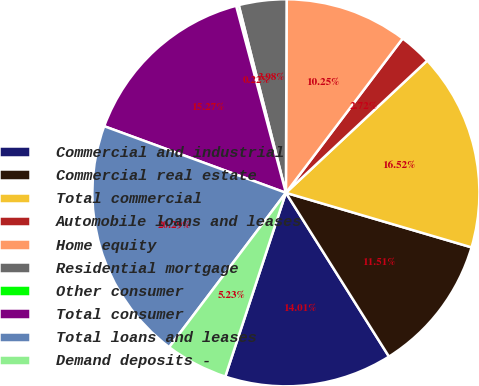Convert chart. <chart><loc_0><loc_0><loc_500><loc_500><pie_chart><fcel>Commercial and industrial<fcel>Commercial real estate<fcel>Total commercial<fcel>Automobile loans and leases<fcel>Home equity<fcel>Residential mortgage<fcel>Other consumer<fcel>Total consumer<fcel>Total loans and leases<fcel>Demand deposits -<nl><fcel>14.01%<fcel>11.51%<fcel>16.52%<fcel>2.72%<fcel>10.25%<fcel>3.98%<fcel>0.22%<fcel>15.27%<fcel>20.29%<fcel>5.23%<nl></chart> 